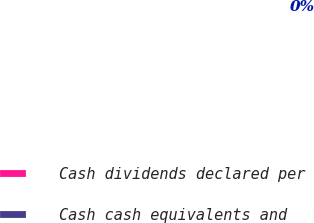Convert chart. <chart><loc_0><loc_0><loc_500><loc_500><pie_chart><fcel>Cash dividends declared per<fcel>Cash cash equivalents and<nl><fcel>0.0%<fcel>100.0%<nl></chart> 